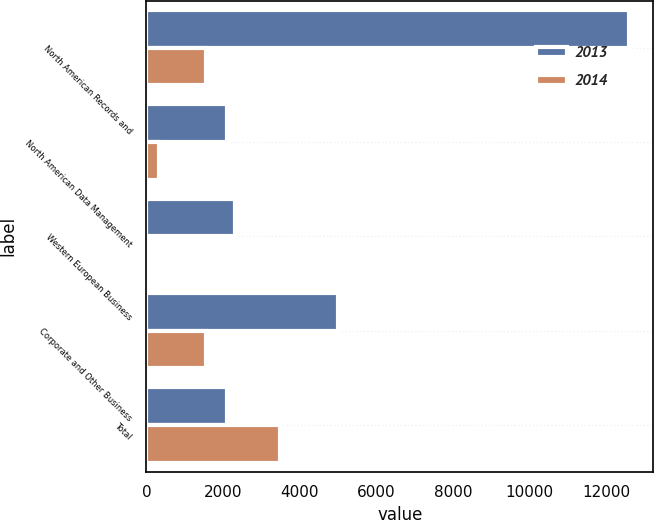<chart> <loc_0><loc_0><loc_500><loc_500><stacked_bar_chart><ecel><fcel>North American Records and<fcel>North American Data Management<fcel>Western European Business<fcel>Corporate and Other Business<fcel>Total<nl><fcel>2013<fcel>12600<fcel>2100<fcel>2300<fcel>5000<fcel>2100<nl><fcel>2014<fcel>1560<fcel>340<fcel>33<fcel>1542<fcel>3475<nl></chart> 